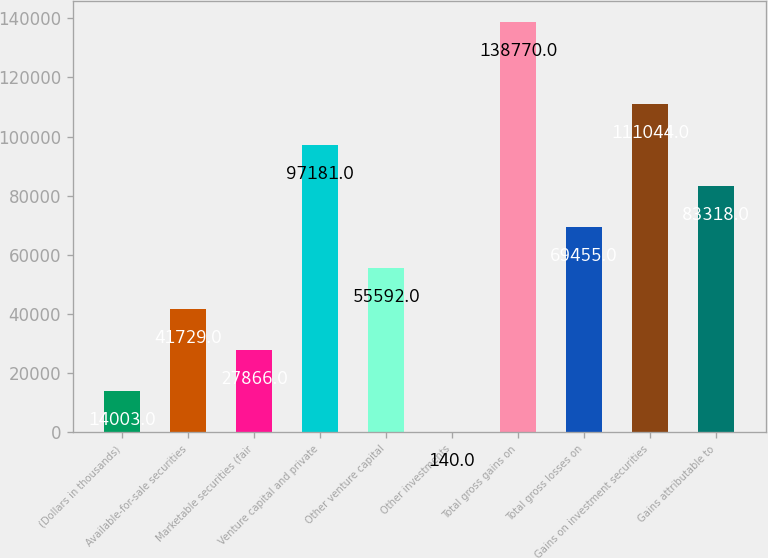<chart> <loc_0><loc_0><loc_500><loc_500><bar_chart><fcel>(Dollars in thousands)<fcel>Available-for-sale securities<fcel>Marketable securities (fair<fcel>Venture capital and private<fcel>Other venture capital<fcel>Other investments<fcel>Total gross gains on<fcel>Total gross losses on<fcel>Gains on investment securities<fcel>Gains attributable to<nl><fcel>14003<fcel>41729<fcel>27866<fcel>97181<fcel>55592<fcel>140<fcel>138770<fcel>69455<fcel>111044<fcel>83318<nl></chart> 